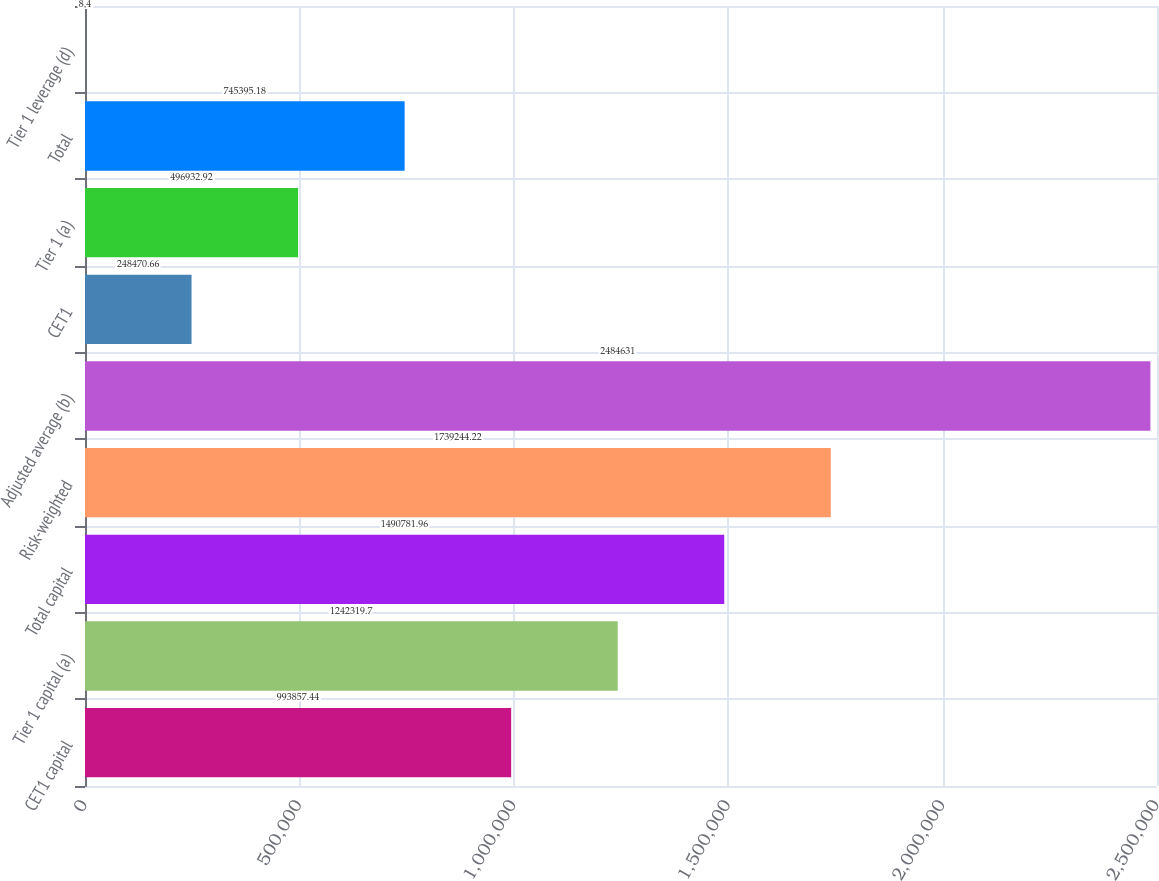Convert chart. <chart><loc_0><loc_0><loc_500><loc_500><bar_chart><fcel>CET1 capital<fcel>Tier 1 capital (a)<fcel>Total capital<fcel>Risk-weighted<fcel>Adjusted average (b)<fcel>CET1<fcel>Tier 1 (a)<fcel>Total<fcel>Tier 1 leverage (d)<nl><fcel>993857<fcel>1.24232e+06<fcel>1.49078e+06<fcel>1.73924e+06<fcel>2.48463e+06<fcel>248471<fcel>496933<fcel>745395<fcel>8.4<nl></chart> 